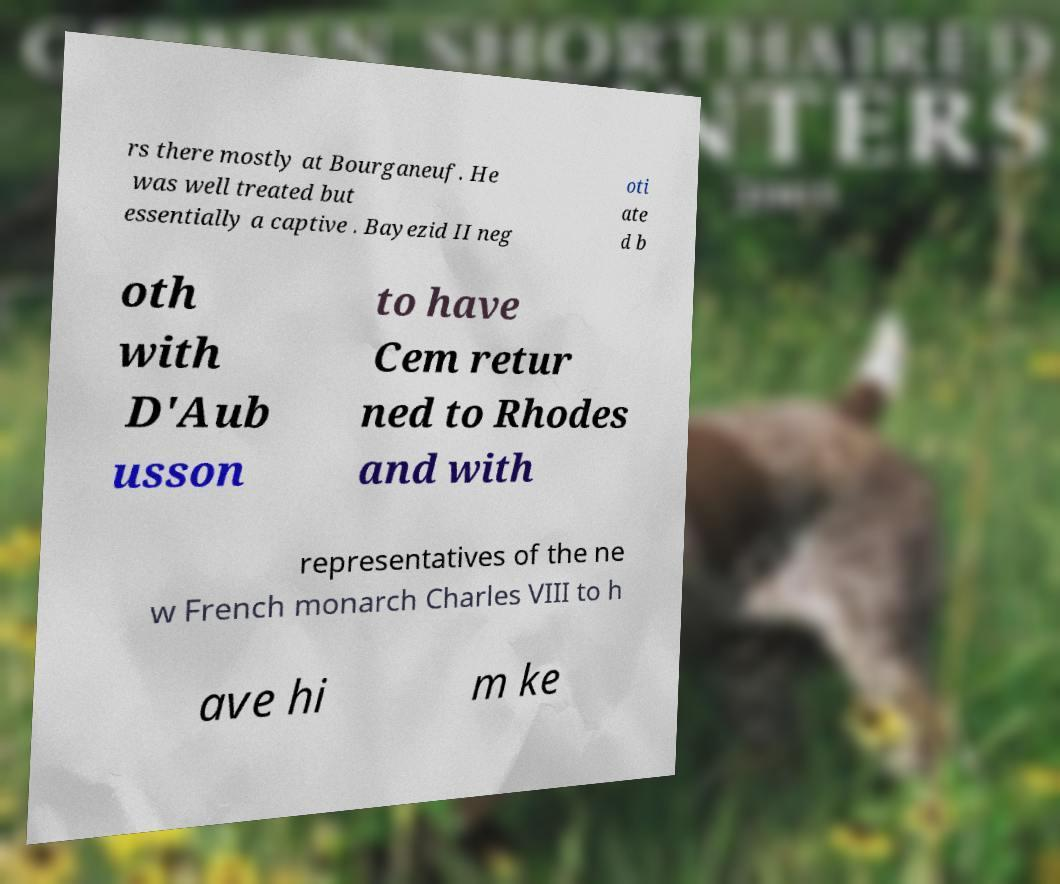What messages or text are displayed in this image? I need them in a readable, typed format. rs there mostly at Bourganeuf. He was well treated but essentially a captive . Bayezid II neg oti ate d b oth with D'Aub usson to have Cem retur ned to Rhodes and with representatives of the ne w French monarch Charles VIII to h ave hi m ke 